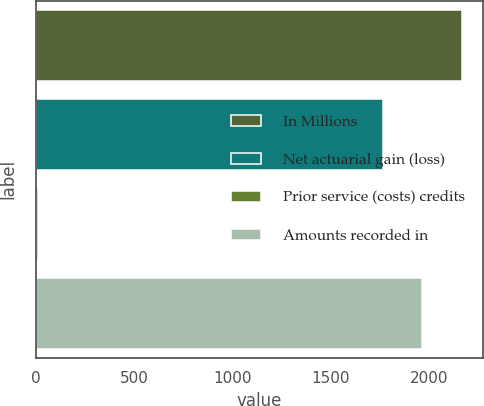Convert chart. <chart><loc_0><loc_0><loc_500><loc_500><bar_chart><fcel>In Millions<fcel>Net actuarial gain (loss)<fcel>Prior service (costs) credits<fcel>Amounts recorded in<nl><fcel>2166.28<fcel>1764.1<fcel>7.1<fcel>1965.19<nl></chart> 